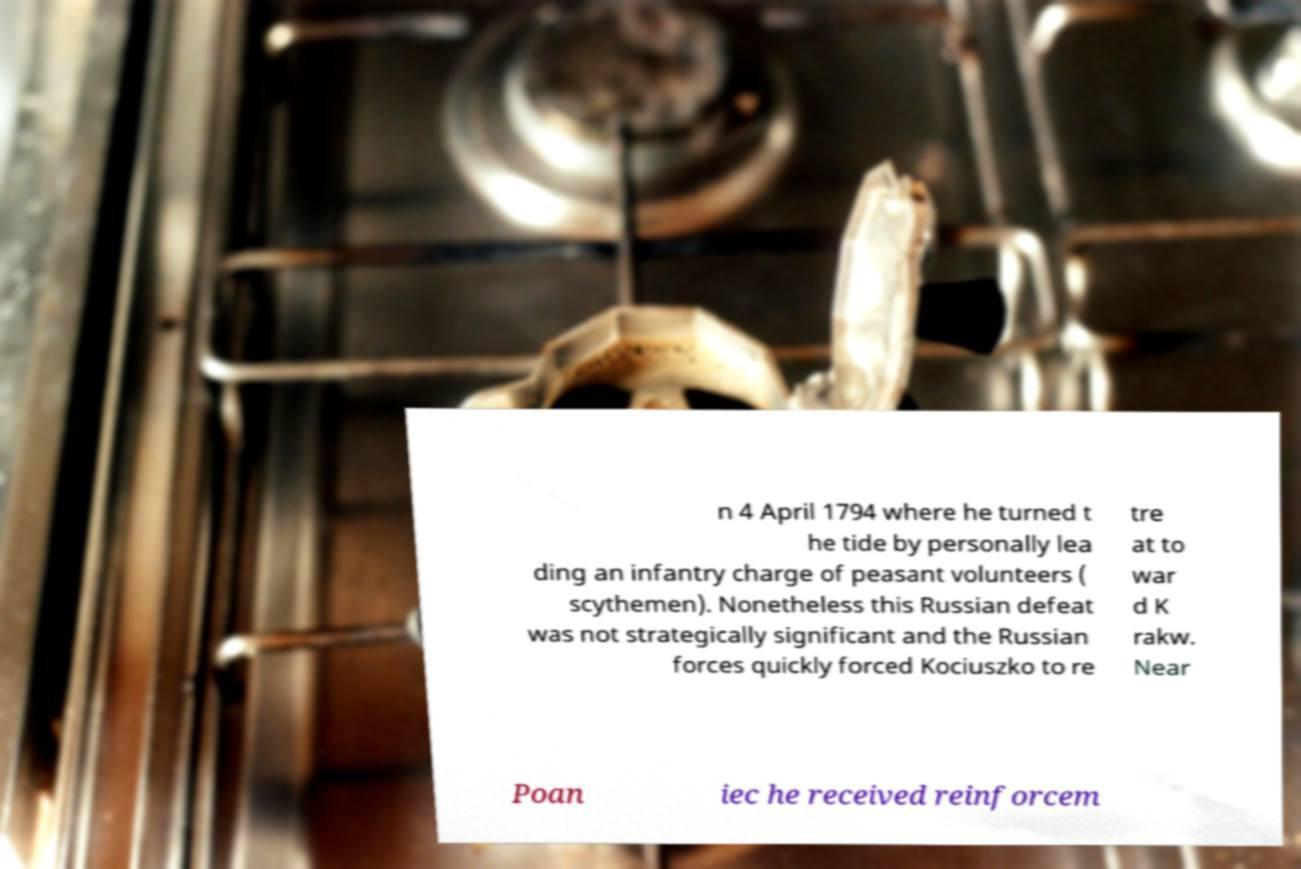Please read and relay the text visible in this image. What does it say? n 4 April 1794 where he turned t he tide by personally lea ding an infantry charge of peasant volunteers ( scythemen). Nonetheless this Russian defeat was not strategically significant and the Russian forces quickly forced Kociuszko to re tre at to war d K rakw. Near Poan iec he received reinforcem 